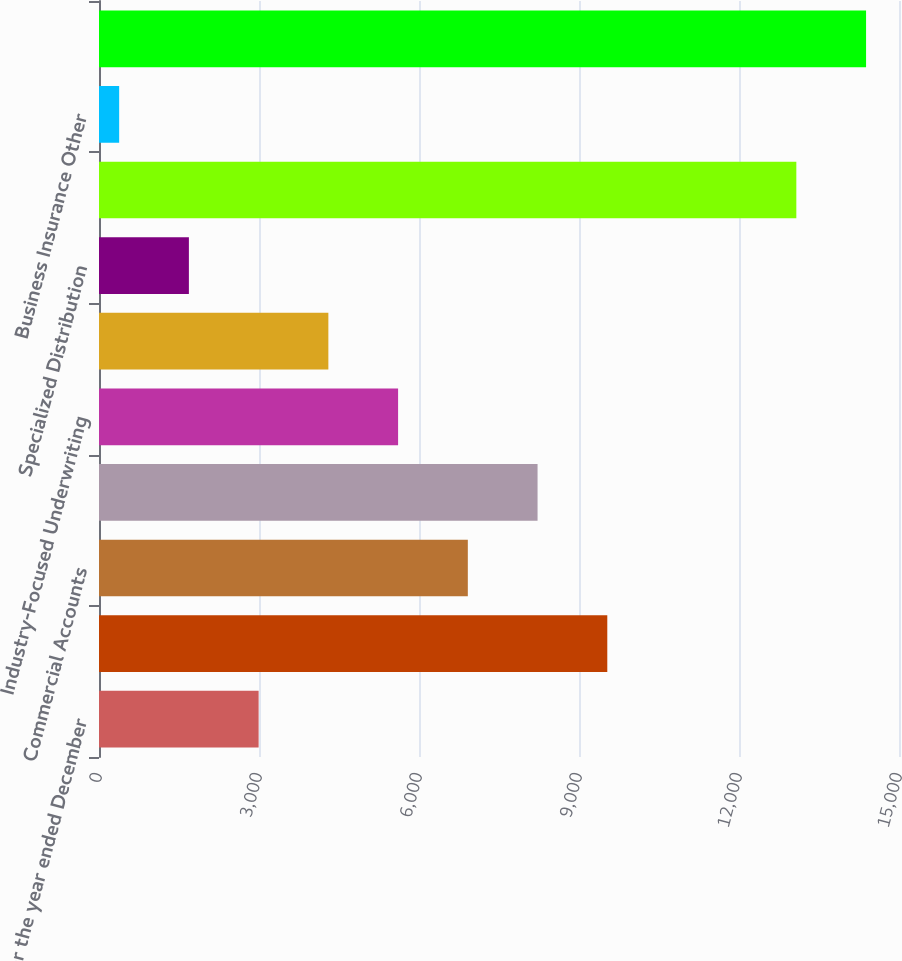Convert chart. <chart><loc_0><loc_0><loc_500><loc_500><bar_chart><fcel>(for the year ended December<fcel>Select Accounts<fcel>Commercial Accounts<fcel>National Accounts<fcel>Industry-Focused Underwriting<fcel>Target Risk Underwriting<fcel>Specialized Distribution<fcel>Total Business Insurance Core<fcel>Business Insurance Other<fcel>Total Business Insurance<nl><fcel>2993<fcel>9530.5<fcel>6915.5<fcel>8223<fcel>5608<fcel>4300.5<fcel>1685.5<fcel>13075<fcel>378<fcel>14382.5<nl></chart> 